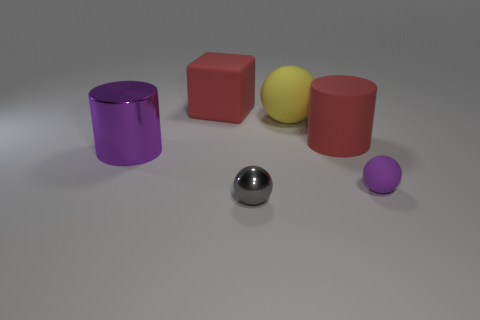What color is the metal ball?
Offer a very short reply. Gray. There is a rubber thing that is the same color as the big rubber block; what shape is it?
Provide a short and direct response. Cylinder. What number of red rubber blocks are in front of the gray shiny object?
Provide a short and direct response. 0. What is the material of the ball that is both in front of the large yellow matte sphere and behind the gray metal thing?
Your answer should be very brief. Rubber. What number of cylinders are either large red matte objects or large objects?
Provide a succinct answer. 2. What material is the big yellow thing that is the same shape as the purple rubber thing?
Provide a succinct answer. Rubber. The yellow thing that is made of the same material as the tiny purple sphere is what size?
Your response must be concise. Large. There is a matte object that is in front of the large purple shiny thing; is its shape the same as the big matte thing that is to the left of the metallic ball?
Make the answer very short. No. What is the color of the large object that is the same material as the small gray thing?
Your answer should be very brief. Purple. There is a red thing in front of the red cube; is it the same size as the ball that is behind the large matte cylinder?
Keep it short and to the point. Yes. 